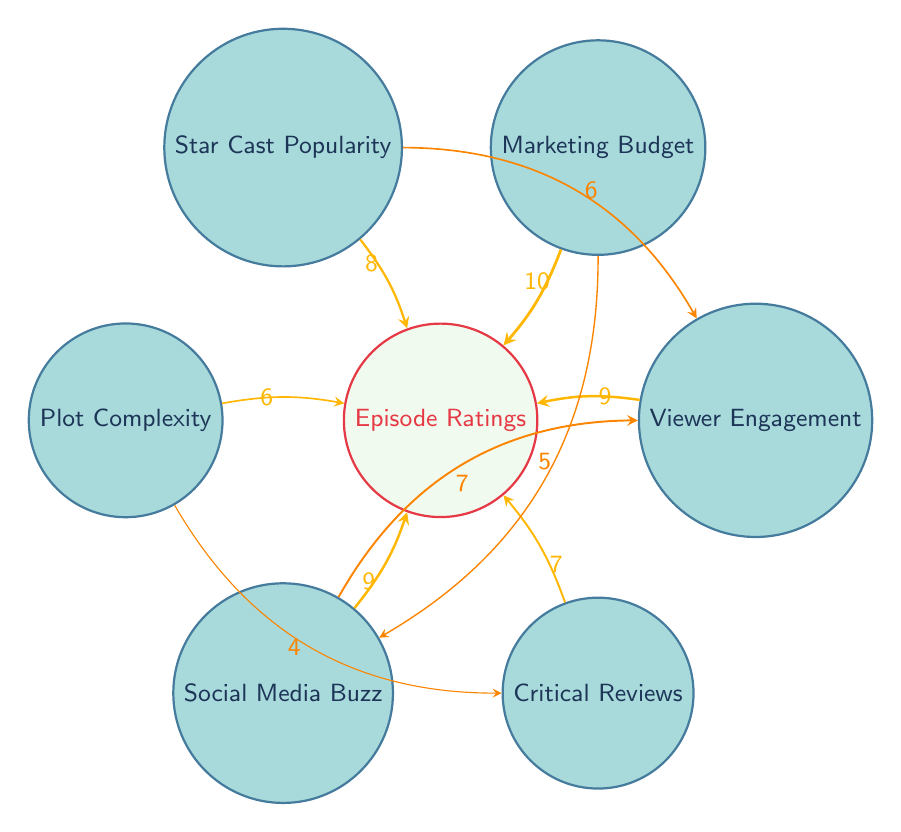What is the value linking Marketing Budget to Episode Ratings? The value indicated in the diagram represents the strength of the connection between the Marketing Budget and Episode Ratings. In this case, the link shows a value of 10, highlighting its significance.
Answer: 10 What is the overall number of nodes present in the diagram? By counting the distinct nodes listed in the diagram, we find that there are a total of 7 nodes: Episode Ratings, Marketing Budget, Star Cast Popularity, Plot Complexity, Social Media Buzz, Critical Reviews, and Viewer Engagement.
Answer: 7 Which factor contributes most to Episode Ratings? Looking at the connections to Episode Ratings, the highest value link is from Marketing Budget, which has a value of 10. This indicates that it has the strongest influence on Episode Ratings compared to other factors.
Answer: Marketing Budget How many factors influence Viewer Engagement? By examining the outgoing connections from the Viewer Engagement node in the diagram, we see it is influenced by Star Cast Popularity and Social Media Buzz. There are two factors influencing it.
Answer: 2 What is the value of the link from Plot Complexity to Critical Reviews? Referencing the diagram, the link from Plot Complexity to Critical Reviews shows a value of 4, indicating a direct influence from Plot Complexity to Critical Reviews.
Answer: 4 What is the relationship between Social Media Buzz and Viewer Engagement? The diagram illustrates a link between Social Media Buzz and Viewer Engagement, with a value of 7, indicating that Social Media Buzz has a moderate influence on Viewer Engagement.
Answer: 7 Is there a direct connection from Star Cast Popularity to Episode Ratings? Yes, the diagram shows a direct connection from Star Cast Popularity to Episode Ratings with a value of 8, demonstrating its positive impact on the ratings.
Answer: Yes What factor has the second highest influence on Episode Ratings? Evaluating the connections, the second highest value linked to Episode Ratings is from Star Cast Popularity, with a value of 8. This shows its strong impact but ranks below Marketing Budget.
Answer: Star Cast Popularity 